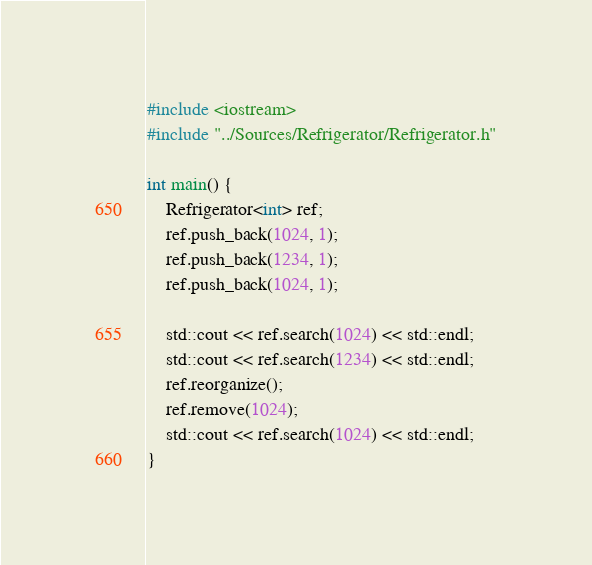Convert code to text. <code><loc_0><loc_0><loc_500><loc_500><_C++_>#include <iostream>
#include "../Sources/Refrigerator/Refrigerator.h"

int main() {
    Refrigerator<int> ref;
    ref.push_back(1024, 1);
    ref.push_back(1234, 1);
    ref.push_back(1024, 1);

    std::cout << ref.search(1024) << std::endl;
    std::cout << ref.search(1234) << std::endl;
    ref.reorganize();
    ref.remove(1024);
    std::cout << ref.search(1024) << std::endl;
}</code> 